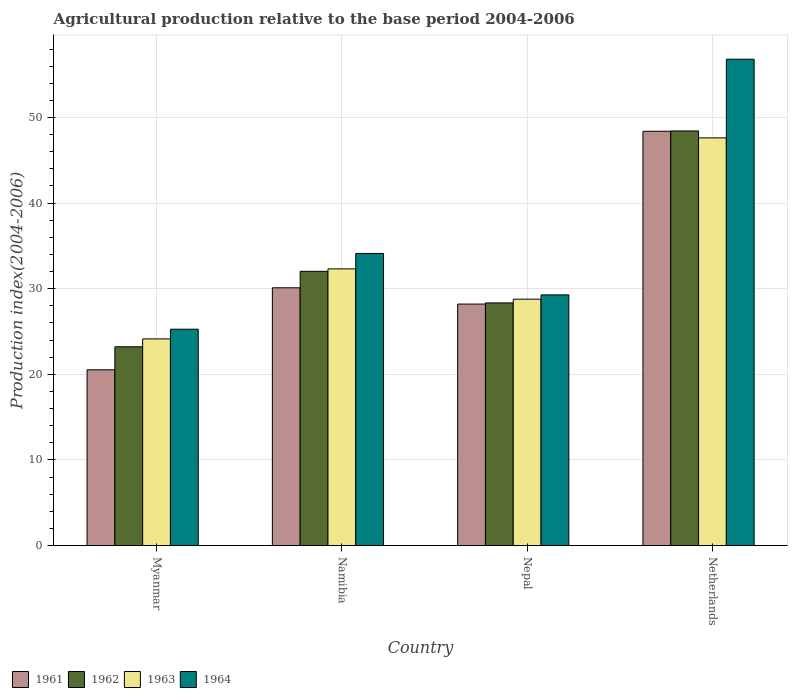How many different coloured bars are there?
Ensure brevity in your answer.  4. How many groups of bars are there?
Ensure brevity in your answer.  4. Are the number of bars on each tick of the X-axis equal?
Give a very brief answer. Yes. How many bars are there on the 2nd tick from the left?
Offer a very short reply. 4. What is the label of the 1st group of bars from the left?
Keep it short and to the point. Myanmar. What is the agricultural production index in 1963 in Nepal?
Offer a terse response. 28.78. Across all countries, what is the maximum agricultural production index in 1964?
Provide a succinct answer. 56.81. Across all countries, what is the minimum agricultural production index in 1964?
Ensure brevity in your answer.  25.27. In which country was the agricultural production index in 1964 maximum?
Provide a succinct answer. Netherlands. In which country was the agricultural production index in 1963 minimum?
Provide a succinct answer. Myanmar. What is the total agricultural production index in 1964 in the graph?
Ensure brevity in your answer.  145.48. What is the difference between the agricultural production index in 1963 in Nepal and that in Netherlands?
Your answer should be compact. -18.84. What is the difference between the agricultural production index in 1962 in Myanmar and the agricultural production index in 1963 in Netherlands?
Offer a very short reply. -24.4. What is the average agricultural production index in 1962 per country?
Make the answer very short. 33.01. What is the difference between the agricultural production index of/in 1962 and agricultural production index of/in 1963 in Netherlands?
Make the answer very short. 0.81. In how many countries, is the agricultural production index in 1963 greater than 6?
Keep it short and to the point. 4. What is the ratio of the agricultural production index in 1963 in Myanmar to that in Nepal?
Provide a short and direct response. 0.84. What is the difference between the highest and the second highest agricultural production index in 1961?
Your response must be concise. 20.18. What is the difference between the highest and the lowest agricultural production index in 1961?
Your answer should be very brief. 27.86. In how many countries, is the agricultural production index in 1961 greater than the average agricultural production index in 1961 taken over all countries?
Your answer should be very brief. 1. Is the sum of the agricultural production index in 1964 in Namibia and Netherlands greater than the maximum agricultural production index in 1962 across all countries?
Keep it short and to the point. Yes. Is it the case that in every country, the sum of the agricultural production index in 1961 and agricultural production index in 1964 is greater than the sum of agricultural production index in 1962 and agricultural production index in 1963?
Give a very brief answer. No. What does the 4th bar from the right in Nepal represents?
Make the answer very short. 1961. How many countries are there in the graph?
Provide a short and direct response. 4. Where does the legend appear in the graph?
Give a very brief answer. Bottom left. How many legend labels are there?
Make the answer very short. 4. What is the title of the graph?
Ensure brevity in your answer.  Agricultural production relative to the base period 2004-2006. What is the label or title of the Y-axis?
Offer a very short reply. Production index(2004-2006). What is the Production index(2004-2006) of 1961 in Myanmar?
Your answer should be very brief. 20.53. What is the Production index(2004-2006) in 1962 in Myanmar?
Your response must be concise. 23.22. What is the Production index(2004-2006) of 1963 in Myanmar?
Your answer should be very brief. 24.14. What is the Production index(2004-2006) of 1964 in Myanmar?
Your response must be concise. 25.27. What is the Production index(2004-2006) in 1961 in Namibia?
Give a very brief answer. 30.11. What is the Production index(2004-2006) of 1962 in Namibia?
Provide a short and direct response. 32.03. What is the Production index(2004-2006) in 1963 in Namibia?
Your response must be concise. 32.32. What is the Production index(2004-2006) in 1964 in Namibia?
Your answer should be compact. 34.12. What is the Production index(2004-2006) in 1961 in Nepal?
Provide a short and direct response. 28.21. What is the Production index(2004-2006) of 1962 in Nepal?
Offer a terse response. 28.34. What is the Production index(2004-2006) of 1963 in Nepal?
Keep it short and to the point. 28.78. What is the Production index(2004-2006) of 1964 in Nepal?
Your response must be concise. 29.28. What is the Production index(2004-2006) in 1961 in Netherlands?
Give a very brief answer. 48.39. What is the Production index(2004-2006) in 1962 in Netherlands?
Provide a succinct answer. 48.43. What is the Production index(2004-2006) of 1963 in Netherlands?
Ensure brevity in your answer.  47.62. What is the Production index(2004-2006) of 1964 in Netherlands?
Offer a very short reply. 56.81. Across all countries, what is the maximum Production index(2004-2006) of 1961?
Your answer should be compact. 48.39. Across all countries, what is the maximum Production index(2004-2006) in 1962?
Keep it short and to the point. 48.43. Across all countries, what is the maximum Production index(2004-2006) in 1963?
Provide a succinct answer. 47.62. Across all countries, what is the maximum Production index(2004-2006) of 1964?
Your answer should be very brief. 56.81. Across all countries, what is the minimum Production index(2004-2006) of 1961?
Your answer should be very brief. 20.53. Across all countries, what is the minimum Production index(2004-2006) of 1962?
Give a very brief answer. 23.22. Across all countries, what is the minimum Production index(2004-2006) of 1963?
Offer a very short reply. 24.14. Across all countries, what is the minimum Production index(2004-2006) in 1964?
Keep it short and to the point. 25.27. What is the total Production index(2004-2006) of 1961 in the graph?
Ensure brevity in your answer.  127.24. What is the total Production index(2004-2006) of 1962 in the graph?
Offer a very short reply. 132.02. What is the total Production index(2004-2006) of 1963 in the graph?
Offer a terse response. 132.86. What is the total Production index(2004-2006) in 1964 in the graph?
Provide a short and direct response. 145.48. What is the difference between the Production index(2004-2006) of 1961 in Myanmar and that in Namibia?
Make the answer very short. -9.58. What is the difference between the Production index(2004-2006) of 1962 in Myanmar and that in Namibia?
Your answer should be very brief. -8.81. What is the difference between the Production index(2004-2006) of 1963 in Myanmar and that in Namibia?
Your answer should be compact. -8.18. What is the difference between the Production index(2004-2006) in 1964 in Myanmar and that in Namibia?
Provide a succinct answer. -8.85. What is the difference between the Production index(2004-2006) of 1961 in Myanmar and that in Nepal?
Provide a short and direct response. -7.68. What is the difference between the Production index(2004-2006) in 1962 in Myanmar and that in Nepal?
Provide a succinct answer. -5.12. What is the difference between the Production index(2004-2006) of 1963 in Myanmar and that in Nepal?
Offer a very short reply. -4.64. What is the difference between the Production index(2004-2006) in 1964 in Myanmar and that in Nepal?
Offer a terse response. -4.01. What is the difference between the Production index(2004-2006) of 1961 in Myanmar and that in Netherlands?
Give a very brief answer. -27.86. What is the difference between the Production index(2004-2006) in 1962 in Myanmar and that in Netherlands?
Your answer should be compact. -25.21. What is the difference between the Production index(2004-2006) in 1963 in Myanmar and that in Netherlands?
Provide a short and direct response. -23.48. What is the difference between the Production index(2004-2006) in 1964 in Myanmar and that in Netherlands?
Offer a very short reply. -31.54. What is the difference between the Production index(2004-2006) in 1961 in Namibia and that in Nepal?
Your answer should be very brief. 1.9. What is the difference between the Production index(2004-2006) in 1962 in Namibia and that in Nepal?
Offer a terse response. 3.69. What is the difference between the Production index(2004-2006) in 1963 in Namibia and that in Nepal?
Your answer should be compact. 3.54. What is the difference between the Production index(2004-2006) of 1964 in Namibia and that in Nepal?
Ensure brevity in your answer.  4.84. What is the difference between the Production index(2004-2006) of 1961 in Namibia and that in Netherlands?
Make the answer very short. -18.28. What is the difference between the Production index(2004-2006) in 1962 in Namibia and that in Netherlands?
Your answer should be compact. -16.4. What is the difference between the Production index(2004-2006) of 1963 in Namibia and that in Netherlands?
Ensure brevity in your answer.  -15.3. What is the difference between the Production index(2004-2006) in 1964 in Namibia and that in Netherlands?
Make the answer very short. -22.69. What is the difference between the Production index(2004-2006) in 1961 in Nepal and that in Netherlands?
Your response must be concise. -20.18. What is the difference between the Production index(2004-2006) of 1962 in Nepal and that in Netherlands?
Provide a short and direct response. -20.09. What is the difference between the Production index(2004-2006) in 1963 in Nepal and that in Netherlands?
Your answer should be compact. -18.84. What is the difference between the Production index(2004-2006) of 1964 in Nepal and that in Netherlands?
Your response must be concise. -27.53. What is the difference between the Production index(2004-2006) of 1961 in Myanmar and the Production index(2004-2006) of 1963 in Namibia?
Give a very brief answer. -11.79. What is the difference between the Production index(2004-2006) of 1961 in Myanmar and the Production index(2004-2006) of 1964 in Namibia?
Your response must be concise. -13.59. What is the difference between the Production index(2004-2006) of 1962 in Myanmar and the Production index(2004-2006) of 1964 in Namibia?
Your response must be concise. -10.9. What is the difference between the Production index(2004-2006) in 1963 in Myanmar and the Production index(2004-2006) in 1964 in Namibia?
Provide a succinct answer. -9.98. What is the difference between the Production index(2004-2006) in 1961 in Myanmar and the Production index(2004-2006) in 1962 in Nepal?
Provide a short and direct response. -7.81. What is the difference between the Production index(2004-2006) of 1961 in Myanmar and the Production index(2004-2006) of 1963 in Nepal?
Your response must be concise. -8.25. What is the difference between the Production index(2004-2006) in 1961 in Myanmar and the Production index(2004-2006) in 1964 in Nepal?
Make the answer very short. -8.75. What is the difference between the Production index(2004-2006) in 1962 in Myanmar and the Production index(2004-2006) in 1963 in Nepal?
Keep it short and to the point. -5.56. What is the difference between the Production index(2004-2006) in 1962 in Myanmar and the Production index(2004-2006) in 1964 in Nepal?
Make the answer very short. -6.06. What is the difference between the Production index(2004-2006) in 1963 in Myanmar and the Production index(2004-2006) in 1964 in Nepal?
Offer a terse response. -5.14. What is the difference between the Production index(2004-2006) of 1961 in Myanmar and the Production index(2004-2006) of 1962 in Netherlands?
Make the answer very short. -27.9. What is the difference between the Production index(2004-2006) of 1961 in Myanmar and the Production index(2004-2006) of 1963 in Netherlands?
Offer a very short reply. -27.09. What is the difference between the Production index(2004-2006) in 1961 in Myanmar and the Production index(2004-2006) in 1964 in Netherlands?
Keep it short and to the point. -36.28. What is the difference between the Production index(2004-2006) of 1962 in Myanmar and the Production index(2004-2006) of 1963 in Netherlands?
Keep it short and to the point. -24.4. What is the difference between the Production index(2004-2006) in 1962 in Myanmar and the Production index(2004-2006) in 1964 in Netherlands?
Your response must be concise. -33.59. What is the difference between the Production index(2004-2006) of 1963 in Myanmar and the Production index(2004-2006) of 1964 in Netherlands?
Your answer should be compact. -32.67. What is the difference between the Production index(2004-2006) in 1961 in Namibia and the Production index(2004-2006) in 1962 in Nepal?
Offer a terse response. 1.77. What is the difference between the Production index(2004-2006) of 1961 in Namibia and the Production index(2004-2006) of 1963 in Nepal?
Offer a terse response. 1.33. What is the difference between the Production index(2004-2006) of 1961 in Namibia and the Production index(2004-2006) of 1964 in Nepal?
Provide a succinct answer. 0.83. What is the difference between the Production index(2004-2006) of 1962 in Namibia and the Production index(2004-2006) of 1964 in Nepal?
Your answer should be very brief. 2.75. What is the difference between the Production index(2004-2006) of 1963 in Namibia and the Production index(2004-2006) of 1964 in Nepal?
Provide a short and direct response. 3.04. What is the difference between the Production index(2004-2006) of 1961 in Namibia and the Production index(2004-2006) of 1962 in Netherlands?
Offer a terse response. -18.32. What is the difference between the Production index(2004-2006) of 1961 in Namibia and the Production index(2004-2006) of 1963 in Netherlands?
Your answer should be compact. -17.51. What is the difference between the Production index(2004-2006) in 1961 in Namibia and the Production index(2004-2006) in 1964 in Netherlands?
Make the answer very short. -26.7. What is the difference between the Production index(2004-2006) of 1962 in Namibia and the Production index(2004-2006) of 1963 in Netherlands?
Provide a short and direct response. -15.59. What is the difference between the Production index(2004-2006) of 1962 in Namibia and the Production index(2004-2006) of 1964 in Netherlands?
Provide a succinct answer. -24.78. What is the difference between the Production index(2004-2006) in 1963 in Namibia and the Production index(2004-2006) in 1964 in Netherlands?
Keep it short and to the point. -24.49. What is the difference between the Production index(2004-2006) in 1961 in Nepal and the Production index(2004-2006) in 1962 in Netherlands?
Your answer should be compact. -20.22. What is the difference between the Production index(2004-2006) in 1961 in Nepal and the Production index(2004-2006) in 1963 in Netherlands?
Make the answer very short. -19.41. What is the difference between the Production index(2004-2006) in 1961 in Nepal and the Production index(2004-2006) in 1964 in Netherlands?
Your response must be concise. -28.6. What is the difference between the Production index(2004-2006) of 1962 in Nepal and the Production index(2004-2006) of 1963 in Netherlands?
Your answer should be compact. -19.28. What is the difference between the Production index(2004-2006) of 1962 in Nepal and the Production index(2004-2006) of 1964 in Netherlands?
Provide a short and direct response. -28.47. What is the difference between the Production index(2004-2006) in 1963 in Nepal and the Production index(2004-2006) in 1964 in Netherlands?
Ensure brevity in your answer.  -28.03. What is the average Production index(2004-2006) in 1961 per country?
Your response must be concise. 31.81. What is the average Production index(2004-2006) in 1962 per country?
Your response must be concise. 33.01. What is the average Production index(2004-2006) of 1963 per country?
Give a very brief answer. 33.22. What is the average Production index(2004-2006) in 1964 per country?
Offer a very short reply. 36.37. What is the difference between the Production index(2004-2006) in 1961 and Production index(2004-2006) in 1962 in Myanmar?
Make the answer very short. -2.69. What is the difference between the Production index(2004-2006) of 1961 and Production index(2004-2006) of 1963 in Myanmar?
Keep it short and to the point. -3.61. What is the difference between the Production index(2004-2006) in 1961 and Production index(2004-2006) in 1964 in Myanmar?
Keep it short and to the point. -4.74. What is the difference between the Production index(2004-2006) in 1962 and Production index(2004-2006) in 1963 in Myanmar?
Offer a terse response. -0.92. What is the difference between the Production index(2004-2006) in 1962 and Production index(2004-2006) in 1964 in Myanmar?
Ensure brevity in your answer.  -2.05. What is the difference between the Production index(2004-2006) of 1963 and Production index(2004-2006) of 1964 in Myanmar?
Ensure brevity in your answer.  -1.13. What is the difference between the Production index(2004-2006) in 1961 and Production index(2004-2006) in 1962 in Namibia?
Make the answer very short. -1.92. What is the difference between the Production index(2004-2006) in 1961 and Production index(2004-2006) in 1963 in Namibia?
Offer a very short reply. -2.21. What is the difference between the Production index(2004-2006) in 1961 and Production index(2004-2006) in 1964 in Namibia?
Provide a short and direct response. -4.01. What is the difference between the Production index(2004-2006) of 1962 and Production index(2004-2006) of 1963 in Namibia?
Your response must be concise. -0.29. What is the difference between the Production index(2004-2006) of 1962 and Production index(2004-2006) of 1964 in Namibia?
Your answer should be compact. -2.09. What is the difference between the Production index(2004-2006) of 1963 and Production index(2004-2006) of 1964 in Namibia?
Ensure brevity in your answer.  -1.8. What is the difference between the Production index(2004-2006) in 1961 and Production index(2004-2006) in 1962 in Nepal?
Provide a short and direct response. -0.13. What is the difference between the Production index(2004-2006) in 1961 and Production index(2004-2006) in 1963 in Nepal?
Ensure brevity in your answer.  -0.57. What is the difference between the Production index(2004-2006) of 1961 and Production index(2004-2006) of 1964 in Nepal?
Offer a very short reply. -1.07. What is the difference between the Production index(2004-2006) in 1962 and Production index(2004-2006) in 1963 in Nepal?
Offer a very short reply. -0.44. What is the difference between the Production index(2004-2006) in 1962 and Production index(2004-2006) in 1964 in Nepal?
Ensure brevity in your answer.  -0.94. What is the difference between the Production index(2004-2006) in 1963 and Production index(2004-2006) in 1964 in Nepal?
Give a very brief answer. -0.5. What is the difference between the Production index(2004-2006) in 1961 and Production index(2004-2006) in 1962 in Netherlands?
Offer a terse response. -0.04. What is the difference between the Production index(2004-2006) of 1961 and Production index(2004-2006) of 1963 in Netherlands?
Offer a terse response. 0.77. What is the difference between the Production index(2004-2006) of 1961 and Production index(2004-2006) of 1964 in Netherlands?
Give a very brief answer. -8.42. What is the difference between the Production index(2004-2006) of 1962 and Production index(2004-2006) of 1963 in Netherlands?
Keep it short and to the point. 0.81. What is the difference between the Production index(2004-2006) of 1962 and Production index(2004-2006) of 1964 in Netherlands?
Your answer should be very brief. -8.38. What is the difference between the Production index(2004-2006) of 1963 and Production index(2004-2006) of 1964 in Netherlands?
Your answer should be compact. -9.19. What is the ratio of the Production index(2004-2006) in 1961 in Myanmar to that in Namibia?
Give a very brief answer. 0.68. What is the ratio of the Production index(2004-2006) in 1962 in Myanmar to that in Namibia?
Offer a terse response. 0.72. What is the ratio of the Production index(2004-2006) of 1963 in Myanmar to that in Namibia?
Your response must be concise. 0.75. What is the ratio of the Production index(2004-2006) of 1964 in Myanmar to that in Namibia?
Provide a short and direct response. 0.74. What is the ratio of the Production index(2004-2006) in 1961 in Myanmar to that in Nepal?
Provide a short and direct response. 0.73. What is the ratio of the Production index(2004-2006) of 1962 in Myanmar to that in Nepal?
Provide a short and direct response. 0.82. What is the ratio of the Production index(2004-2006) of 1963 in Myanmar to that in Nepal?
Offer a terse response. 0.84. What is the ratio of the Production index(2004-2006) of 1964 in Myanmar to that in Nepal?
Your answer should be compact. 0.86. What is the ratio of the Production index(2004-2006) of 1961 in Myanmar to that in Netherlands?
Provide a short and direct response. 0.42. What is the ratio of the Production index(2004-2006) in 1962 in Myanmar to that in Netherlands?
Offer a terse response. 0.48. What is the ratio of the Production index(2004-2006) of 1963 in Myanmar to that in Netherlands?
Your response must be concise. 0.51. What is the ratio of the Production index(2004-2006) in 1964 in Myanmar to that in Netherlands?
Ensure brevity in your answer.  0.44. What is the ratio of the Production index(2004-2006) of 1961 in Namibia to that in Nepal?
Keep it short and to the point. 1.07. What is the ratio of the Production index(2004-2006) of 1962 in Namibia to that in Nepal?
Provide a short and direct response. 1.13. What is the ratio of the Production index(2004-2006) of 1963 in Namibia to that in Nepal?
Provide a short and direct response. 1.12. What is the ratio of the Production index(2004-2006) in 1964 in Namibia to that in Nepal?
Offer a very short reply. 1.17. What is the ratio of the Production index(2004-2006) in 1961 in Namibia to that in Netherlands?
Your answer should be very brief. 0.62. What is the ratio of the Production index(2004-2006) of 1962 in Namibia to that in Netherlands?
Your response must be concise. 0.66. What is the ratio of the Production index(2004-2006) in 1963 in Namibia to that in Netherlands?
Your response must be concise. 0.68. What is the ratio of the Production index(2004-2006) of 1964 in Namibia to that in Netherlands?
Ensure brevity in your answer.  0.6. What is the ratio of the Production index(2004-2006) in 1961 in Nepal to that in Netherlands?
Ensure brevity in your answer.  0.58. What is the ratio of the Production index(2004-2006) in 1962 in Nepal to that in Netherlands?
Your response must be concise. 0.59. What is the ratio of the Production index(2004-2006) of 1963 in Nepal to that in Netherlands?
Give a very brief answer. 0.6. What is the ratio of the Production index(2004-2006) in 1964 in Nepal to that in Netherlands?
Give a very brief answer. 0.52. What is the difference between the highest and the second highest Production index(2004-2006) in 1961?
Keep it short and to the point. 18.28. What is the difference between the highest and the second highest Production index(2004-2006) in 1964?
Your response must be concise. 22.69. What is the difference between the highest and the lowest Production index(2004-2006) of 1961?
Offer a very short reply. 27.86. What is the difference between the highest and the lowest Production index(2004-2006) in 1962?
Provide a succinct answer. 25.21. What is the difference between the highest and the lowest Production index(2004-2006) in 1963?
Give a very brief answer. 23.48. What is the difference between the highest and the lowest Production index(2004-2006) in 1964?
Provide a succinct answer. 31.54. 